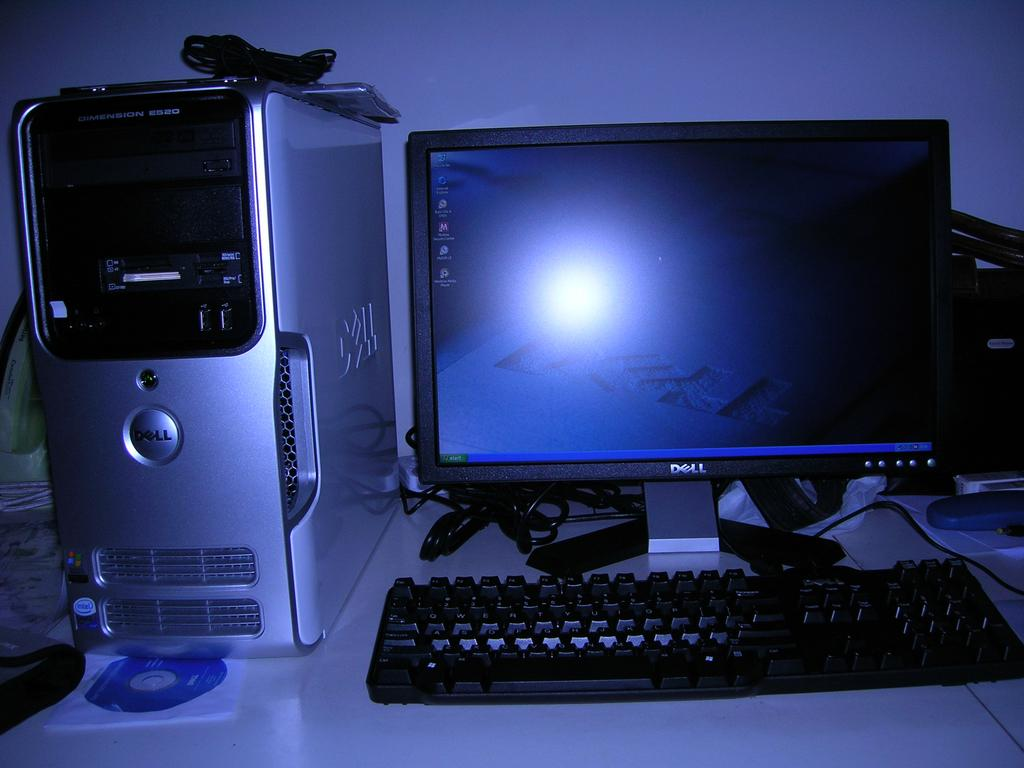<image>
Render a clear and concise summary of the photo. A Dell computer sitting on a desk with their home screen visible. 